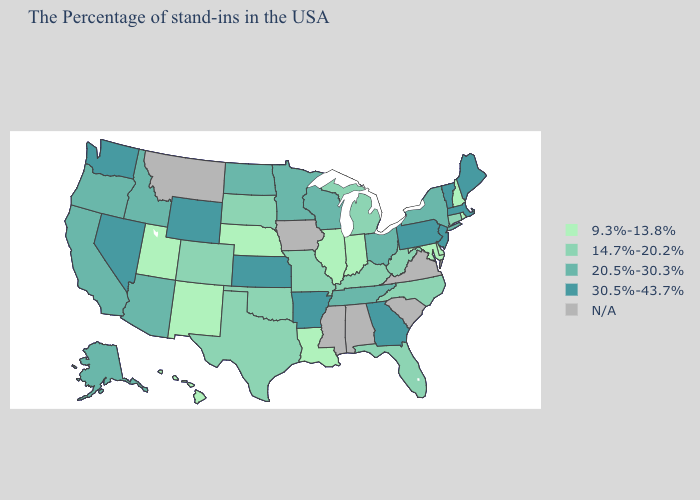Does the map have missing data?
Be succinct. Yes. What is the highest value in states that border Iowa?
Short answer required. 20.5%-30.3%. Among the states that border Missouri , does Arkansas have the highest value?
Be succinct. Yes. Name the states that have a value in the range 30.5%-43.7%?
Answer briefly. Maine, Massachusetts, Vermont, New Jersey, Pennsylvania, Georgia, Arkansas, Kansas, Wyoming, Nevada, Washington. What is the value of North Carolina?
Write a very short answer. 14.7%-20.2%. What is the value of New Mexico?
Write a very short answer. 9.3%-13.8%. Name the states that have a value in the range 9.3%-13.8%?
Short answer required. Rhode Island, New Hampshire, Delaware, Maryland, Indiana, Illinois, Louisiana, Nebraska, New Mexico, Utah, Hawaii. Does Florida have the highest value in the South?
Quick response, please. No. Does the first symbol in the legend represent the smallest category?
Quick response, please. Yes. What is the value of Nevada?
Write a very short answer. 30.5%-43.7%. Name the states that have a value in the range 20.5%-30.3%?
Give a very brief answer. New York, Ohio, Tennessee, Wisconsin, Minnesota, North Dakota, Arizona, Idaho, California, Oregon, Alaska. Name the states that have a value in the range N/A?
Write a very short answer. Virginia, South Carolina, Alabama, Mississippi, Iowa, Montana. What is the lowest value in states that border Pennsylvania?
Be succinct. 9.3%-13.8%. 